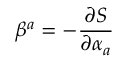Convert formula to latex. <formula><loc_0><loc_0><loc_500><loc_500>\beta ^ { a } = - \frac { \partial S } { \partial \alpha _ { a } }</formula> 